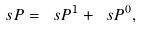Convert formula to latex. <formula><loc_0><loc_0><loc_500><loc_500>\ s P = \ s P ^ { 1 } + \ s P ^ { 0 } ,</formula> 